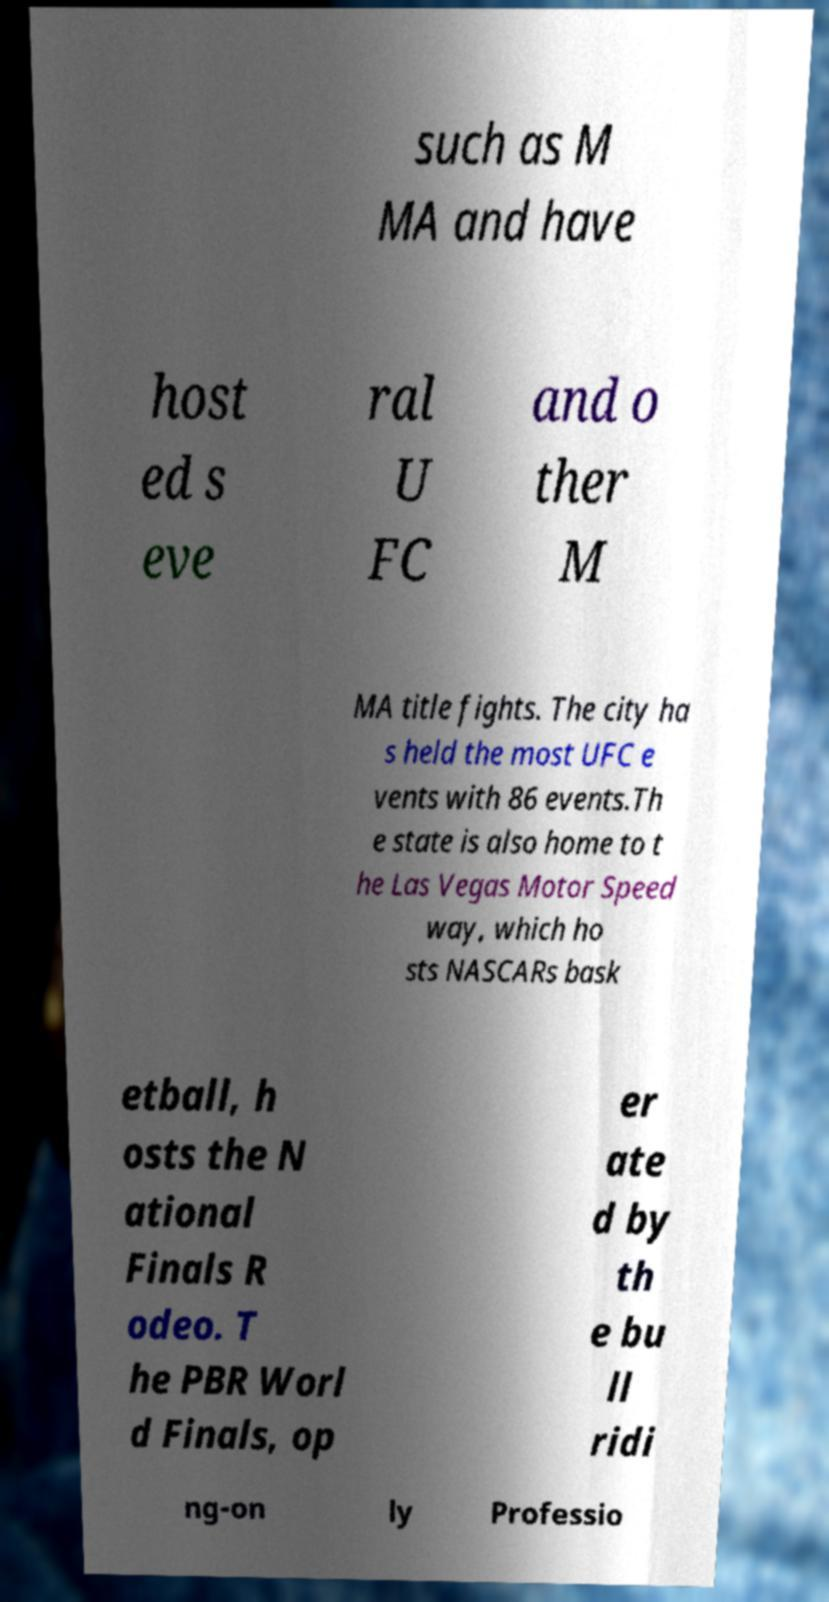I need the written content from this picture converted into text. Can you do that? such as M MA and have host ed s eve ral U FC and o ther M MA title fights. The city ha s held the most UFC e vents with 86 events.Th e state is also home to t he Las Vegas Motor Speed way, which ho sts NASCARs bask etball, h osts the N ational Finals R odeo. T he PBR Worl d Finals, op er ate d by th e bu ll ridi ng-on ly Professio 